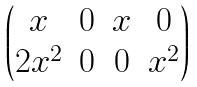<formula> <loc_0><loc_0><loc_500><loc_500>\begin{pmatrix} x & 0 & x & 0 \\ 2 x ^ { 2 } & 0 & 0 & x ^ { 2 } \\ \end{pmatrix}</formula> 